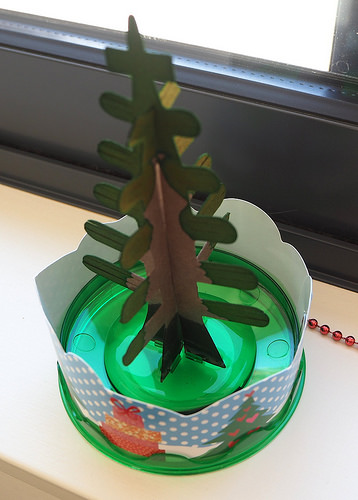<image>
Is the tree next to the plate? No. The tree is not positioned next to the plate. They are located in different areas of the scene. 